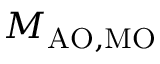<formula> <loc_0><loc_0><loc_500><loc_500>M _ { A O , M O }</formula> 